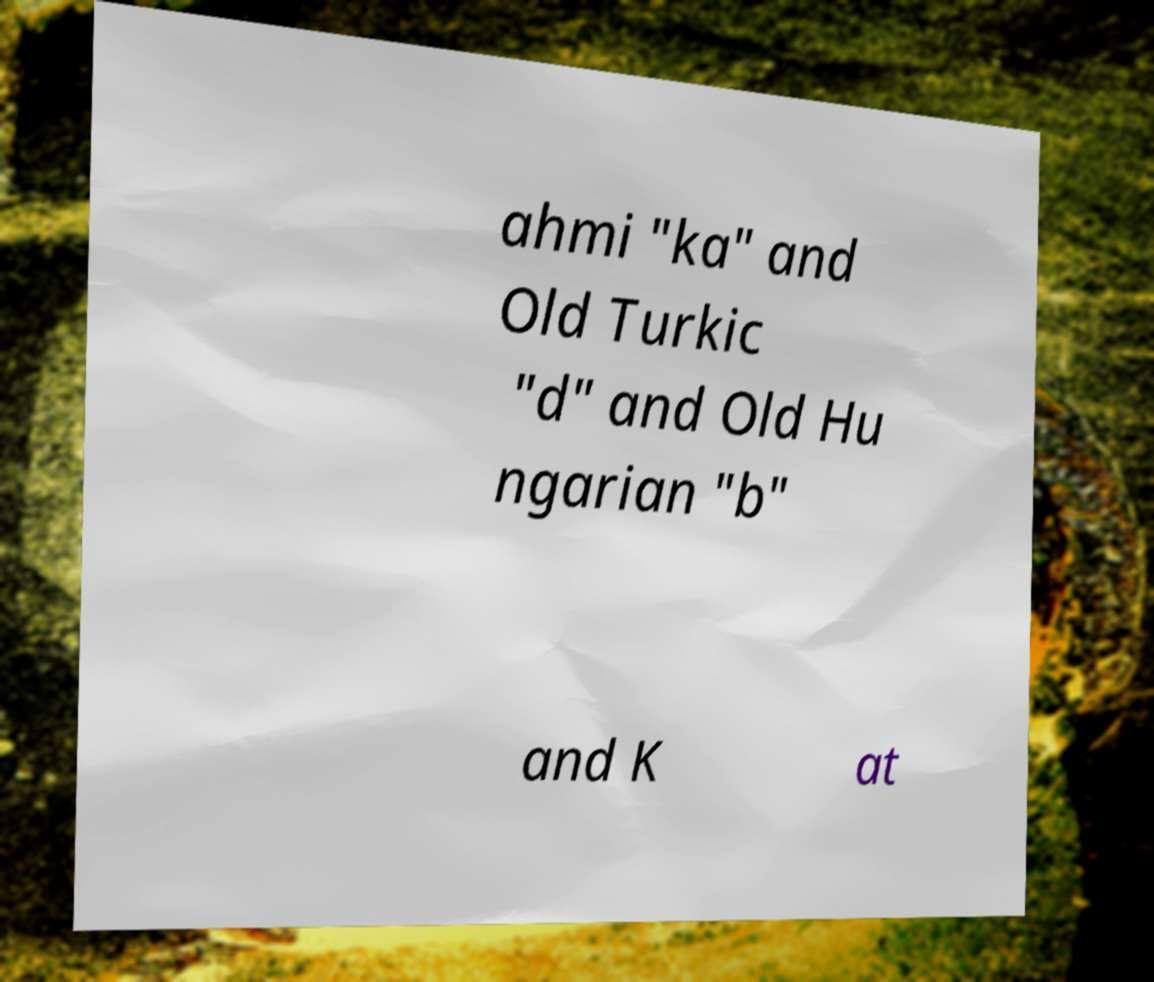For documentation purposes, I need the text within this image transcribed. Could you provide that? ahmi "ka" and Old Turkic "d" and Old Hu ngarian "b" and K at 